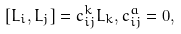<formula> <loc_0><loc_0><loc_500><loc_500>[ L _ { i } , L _ { j } ] = c _ { i j } ^ { k } L _ { k } , c _ { i j } ^ { a } = 0 ,</formula> 